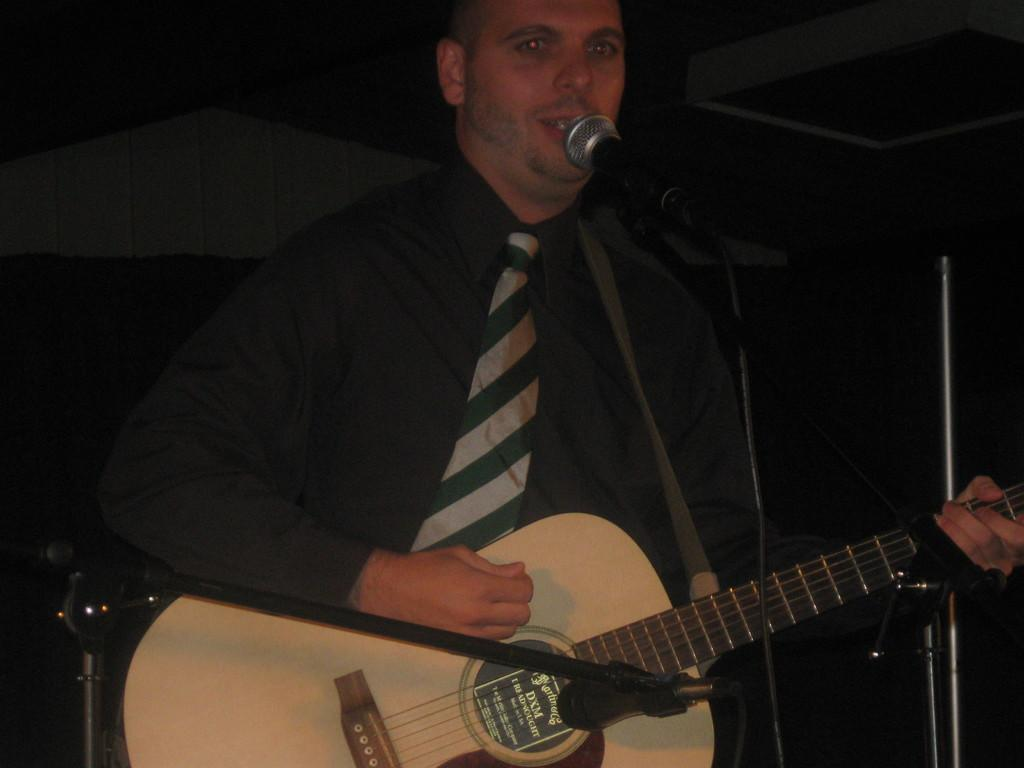What is the man in the image holding? The man is holding a guitar. What activity is the man engaged in? The man is singing a song. What device is the man using to amplify his voice? The man is using a mic while singing. How many trees can be seen in the image? There are no trees visible in the image; it features a man holding a guitar and singing into a mic. What type of top is the man wearing in the image? There is no information about the man's clothing in the provided facts, so it cannot be determined from the image. 